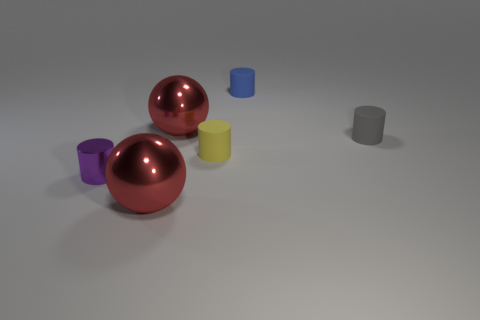Add 2 small brown rubber cubes. How many objects exist? 8 Subtract all spheres. How many objects are left? 4 Subtract 0 blue blocks. How many objects are left? 6 Subtract all tiny gray spheres. Subtract all small blue cylinders. How many objects are left? 5 Add 5 metal balls. How many metal balls are left? 7 Add 3 gray things. How many gray things exist? 4 